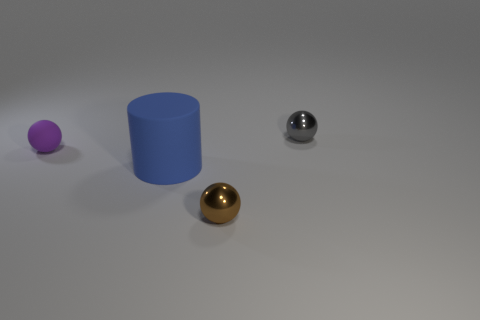Add 3 small gray objects. How many objects exist? 7 Subtract all cylinders. How many objects are left? 3 Add 3 gray shiny spheres. How many gray shiny spheres are left? 4 Add 4 yellow matte spheres. How many yellow matte spheres exist? 4 Subtract 0 red cubes. How many objects are left? 4 Subtract all big blue rubber cubes. Subtract all small gray metal things. How many objects are left? 3 